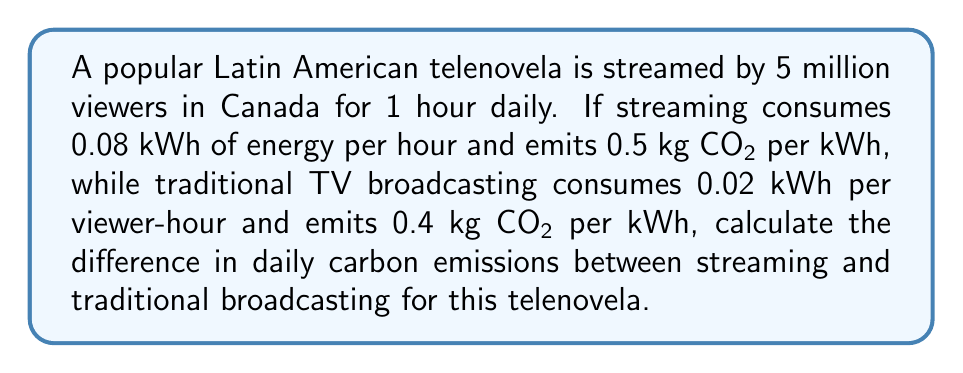Teach me how to tackle this problem. Let's approach this step-by-step:

1. Calculate emissions from streaming:
   - Energy consumption: $5,000,000 \times 1 \times 0.08 = 400,000$ kWh
   - CO₂ emissions: $400,000 \times 0.5 = 200,000$ kg CO₂

2. Calculate emissions from traditional broadcasting:
   - Energy consumption: $5,000,000 \times 1 \times 0.02 = 100,000$ kWh
   - CO₂ emissions: $100,000 \times 0.4 = 40,000$ kg CO₂

3. Calculate the difference:
   $200,000 - 40,000 = 160,000$ kg CO₂

Therefore, streaming the telenovela produces 160,000 kg (or 160 metric tons) more CO₂ per day compared to traditional broadcasting.
Answer: 160,000 kg CO₂ 